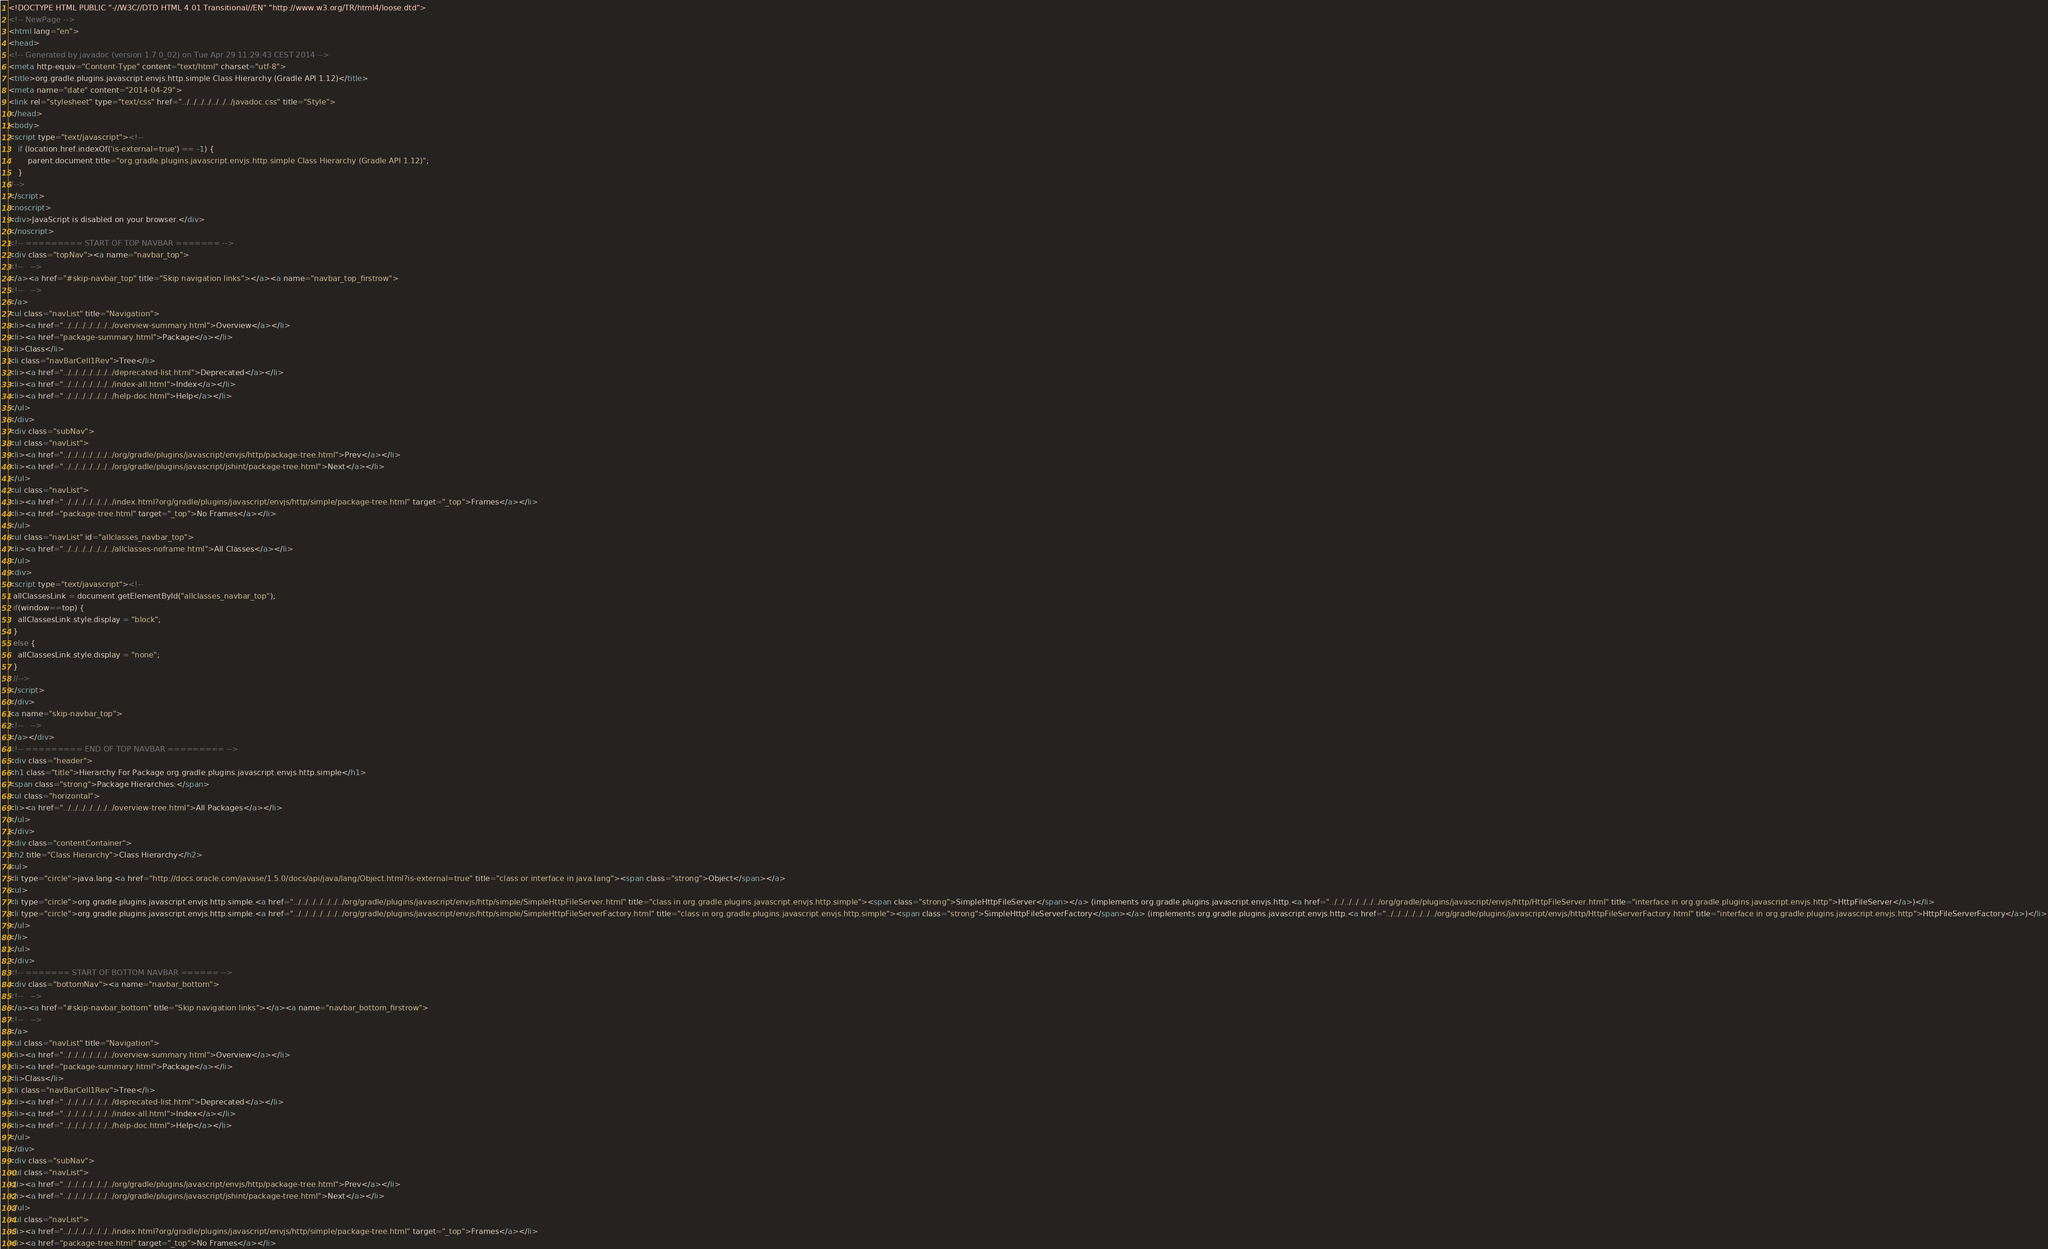Convert code to text. <code><loc_0><loc_0><loc_500><loc_500><_HTML_><!DOCTYPE HTML PUBLIC "-//W3C//DTD HTML 4.01 Transitional//EN" "http://www.w3.org/TR/html4/loose.dtd">
<!-- NewPage -->
<html lang="en">
<head>
<!-- Generated by javadoc (version 1.7.0_02) on Tue Apr 29 11:29:43 CEST 2014 -->
<meta http-equiv="Content-Type" content="text/html" charset="utf-8">
<title>org.gradle.plugins.javascript.envjs.http.simple Class Hierarchy (Gradle API 1.12)</title>
<meta name="date" content="2014-04-29">
<link rel="stylesheet" type="text/css" href="../../../../../../../javadoc.css" title="Style">
</head>
<body>
<script type="text/javascript"><!--
    if (location.href.indexOf('is-external=true') == -1) {
        parent.document.title="org.gradle.plugins.javascript.envjs.http.simple Class Hierarchy (Gradle API 1.12)";
    }
//-->
</script>
<noscript>
<div>JavaScript is disabled on your browser.</div>
</noscript>
<!-- ========= START OF TOP NAVBAR ======= -->
<div class="topNav"><a name="navbar_top">
<!--   -->
</a><a href="#skip-navbar_top" title="Skip navigation links"></a><a name="navbar_top_firstrow">
<!--   -->
</a>
<ul class="navList" title="Navigation">
<li><a href="../../../../../../../overview-summary.html">Overview</a></li>
<li><a href="package-summary.html">Package</a></li>
<li>Class</li>
<li class="navBarCell1Rev">Tree</li>
<li><a href="../../../../../../../deprecated-list.html">Deprecated</a></li>
<li><a href="../../../../../../../index-all.html">Index</a></li>
<li><a href="../../../../../../../help-doc.html">Help</a></li>
</ul>
</div>
<div class="subNav">
<ul class="navList">
<li><a href="../../../../../../../org/gradle/plugins/javascript/envjs/http/package-tree.html">Prev</a></li>
<li><a href="../../../../../../../org/gradle/plugins/javascript/jshint/package-tree.html">Next</a></li>
</ul>
<ul class="navList">
<li><a href="../../../../../../../index.html?org/gradle/plugins/javascript/envjs/http/simple/package-tree.html" target="_top">Frames</a></li>
<li><a href="package-tree.html" target="_top">No Frames</a></li>
</ul>
<ul class="navList" id="allclasses_navbar_top">
<li><a href="../../../../../../../allclasses-noframe.html">All Classes</a></li>
</ul>
<div>
<script type="text/javascript"><!--
  allClassesLink = document.getElementById("allclasses_navbar_top");
  if(window==top) {
    allClassesLink.style.display = "block";
  }
  else {
    allClassesLink.style.display = "none";
  }
  //-->
</script>
</div>
<a name="skip-navbar_top">
<!--   -->
</a></div>
<!-- ========= END OF TOP NAVBAR ========= -->
<div class="header">
<h1 class="title">Hierarchy For Package org.gradle.plugins.javascript.envjs.http.simple</h1>
<span class="strong">Package Hierarchies:</span>
<ul class="horizontal">
<li><a href="../../../../../../../overview-tree.html">All Packages</a></li>
</ul>
</div>
<div class="contentContainer">
<h2 title="Class Hierarchy">Class Hierarchy</h2>
<ul>
<li type="circle">java.lang.<a href="http://docs.oracle.com/javase/1.5.0/docs/api/java/lang/Object.html?is-external=true" title="class or interface in java.lang"><span class="strong">Object</span></a>
<ul>
<li type="circle">org.gradle.plugins.javascript.envjs.http.simple.<a href="../../../../../../../org/gradle/plugins/javascript/envjs/http/simple/SimpleHttpFileServer.html" title="class in org.gradle.plugins.javascript.envjs.http.simple"><span class="strong">SimpleHttpFileServer</span></a> (implements org.gradle.plugins.javascript.envjs.http.<a href="../../../../../../../org/gradle/plugins/javascript/envjs/http/HttpFileServer.html" title="interface in org.gradle.plugins.javascript.envjs.http">HttpFileServer</a>)</li>
<li type="circle">org.gradle.plugins.javascript.envjs.http.simple.<a href="../../../../../../../org/gradle/plugins/javascript/envjs/http/simple/SimpleHttpFileServerFactory.html" title="class in org.gradle.plugins.javascript.envjs.http.simple"><span class="strong">SimpleHttpFileServerFactory</span></a> (implements org.gradle.plugins.javascript.envjs.http.<a href="../../../../../../../org/gradle/plugins/javascript/envjs/http/HttpFileServerFactory.html" title="interface in org.gradle.plugins.javascript.envjs.http">HttpFileServerFactory</a>)</li>
</ul>
</li>
</ul>
</div>
<!-- ======= START OF BOTTOM NAVBAR ====== -->
<div class="bottomNav"><a name="navbar_bottom">
<!--   -->
</a><a href="#skip-navbar_bottom" title="Skip navigation links"></a><a name="navbar_bottom_firstrow">
<!--   -->
</a>
<ul class="navList" title="Navigation">
<li><a href="../../../../../../../overview-summary.html">Overview</a></li>
<li><a href="package-summary.html">Package</a></li>
<li>Class</li>
<li class="navBarCell1Rev">Tree</li>
<li><a href="../../../../../../../deprecated-list.html">Deprecated</a></li>
<li><a href="../../../../../../../index-all.html">Index</a></li>
<li><a href="../../../../../../../help-doc.html">Help</a></li>
</ul>
</div>
<div class="subNav">
<ul class="navList">
<li><a href="../../../../../../../org/gradle/plugins/javascript/envjs/http/package-tree.html">Prev</a></li>
<li><a href="../../../../../../../org/gradle/plugins/javascript/jshint/package-tree.html">Next</a></li>
</ul>
<ul class="navList">
<li><a href="../../../../../../../index.html?org/gradle/plugins/javascript/envjs/http/simple/package-tree.html" target="_top">Frames</a></li>
<li><a href="package-tree.html" target="_top">No Frames</a></li></code> 